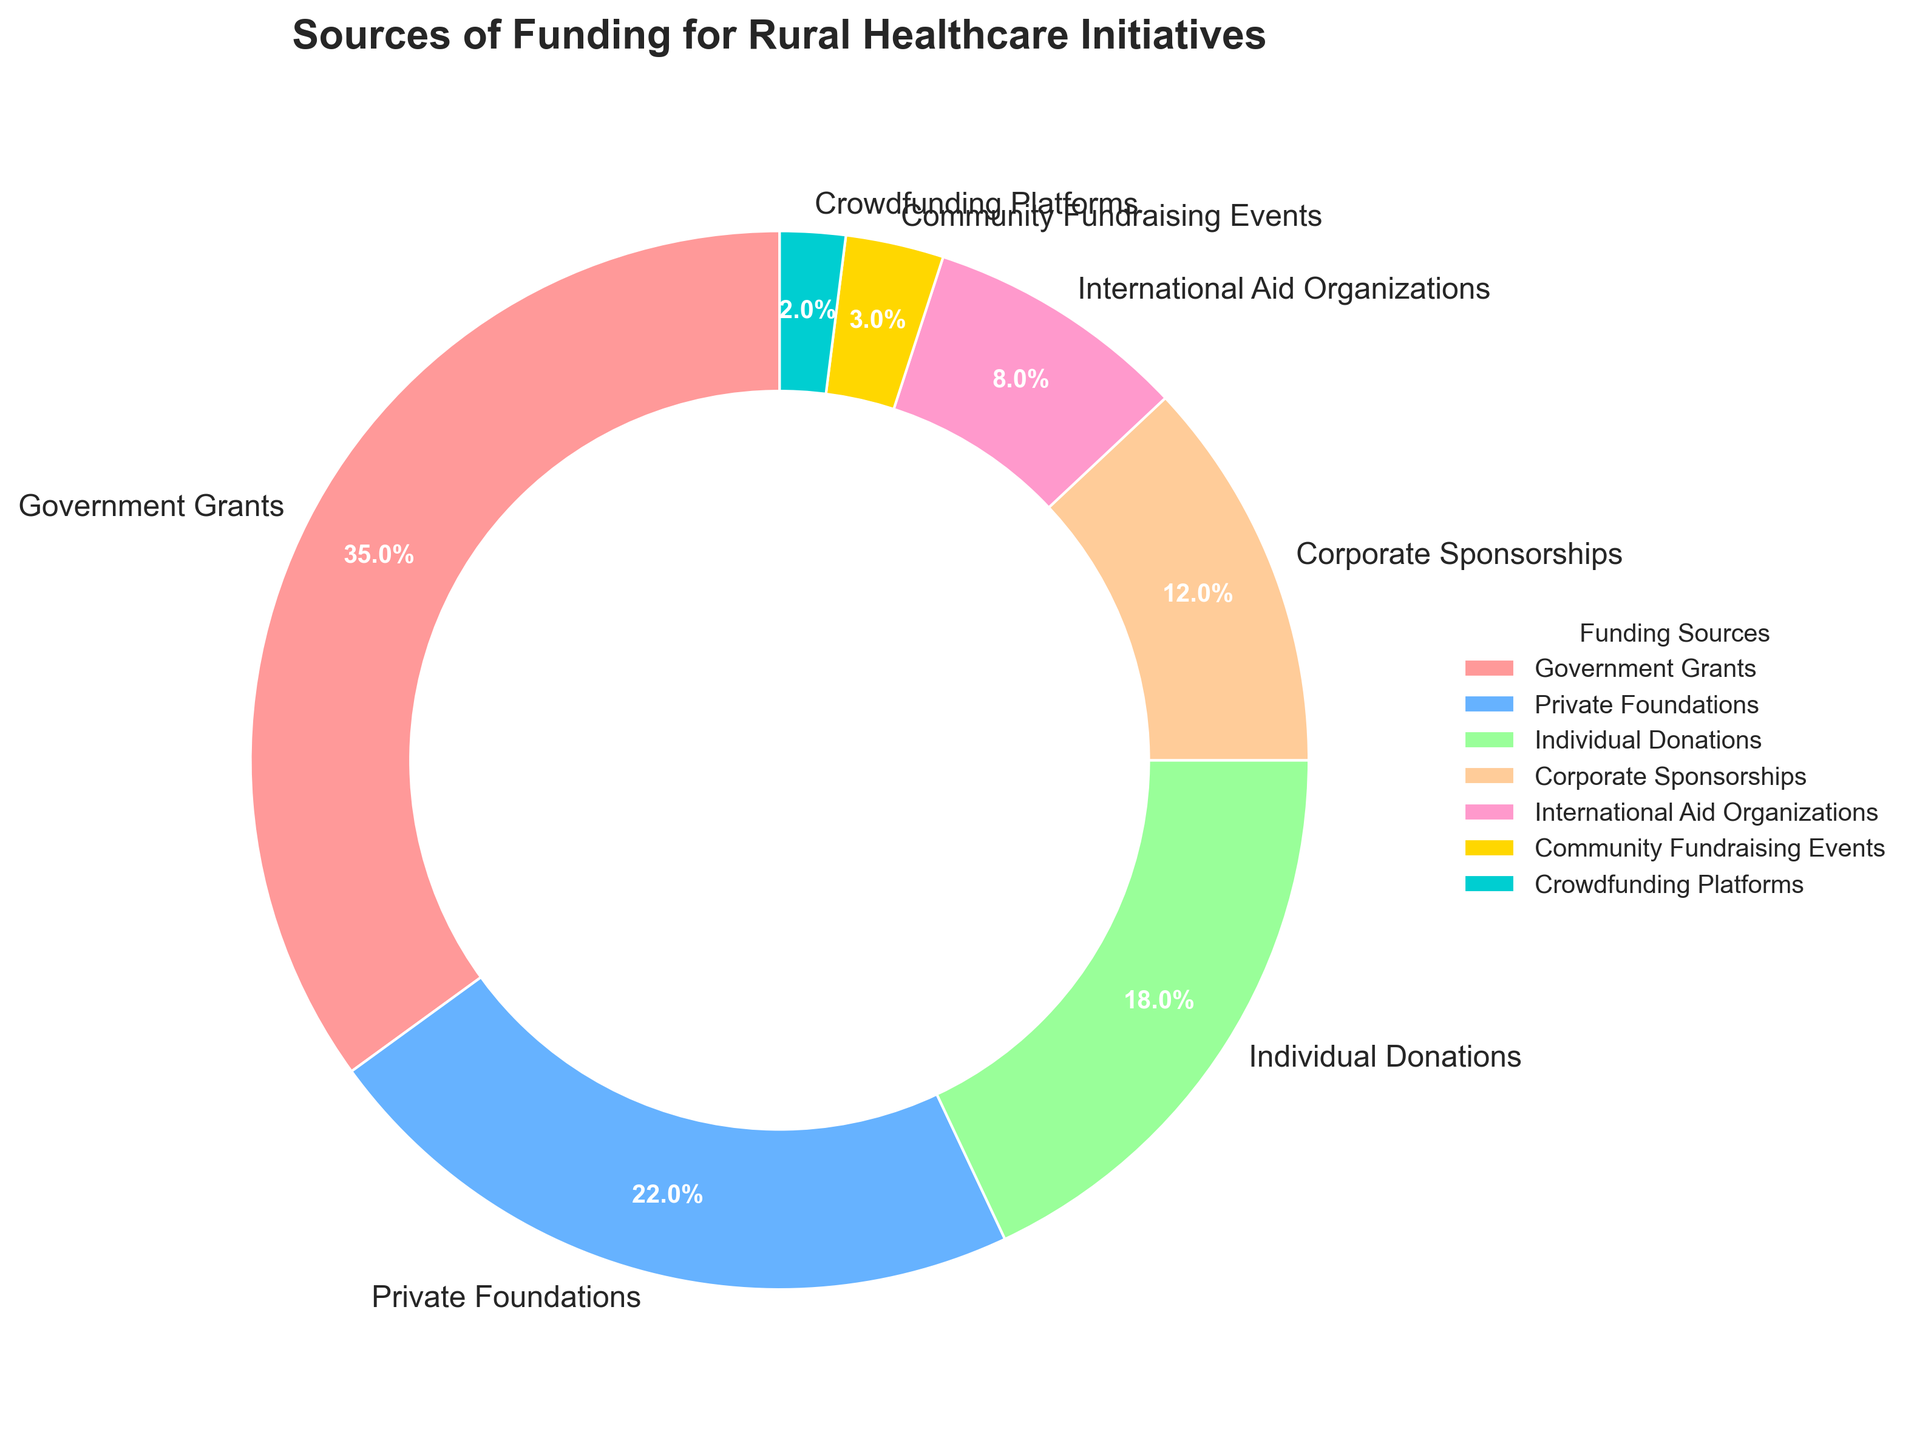What is the largest source of funding for rural healthcare initiatives? The largest segment in the pie chart is the one for Government Grants. It is visually the largest and constitutes 35% of the total funding.
Answer: Government Grants Which two funding sources together make up more than half of the total funding? Government Grants (35%) and Private Foundations (22%) together total 35% + 22% = 57%, which is more than half of the total funding.
Answer: Government Grants and Private Foundations How much more percentage does Individual Donations contribute compared to Corporate Sponsorships? Individual Donations contribute 18% while Corporate Sponsorships contribute 12%. The difference is 18% - 12% = 6%.
Answer: 6% What is the combined percentage of funding from International Aid Organizations, Community Fundraising Events, and Crowdfunding Platforms? The percentages are 8%, 3%, and 2% respectively. Combined, they total 8% + 3% + 2% = 13%.
Answer: 13% Which funding source is represented by the smallest slice in the chart? The smallest slice in the pie chart corresponds to Crowdfunding Platforms, which contribute 2%.
Answer: Crowdfunding Platforms Is the contribution from Private Foundations greater than the combined contribution from International Aid Organizations and Crowdfunding Platforms? Private Foundations contribute 22%. The combined contribution from International Aid Organizations (8%) and Crowdfunding Platforms (2%) is 8% + 2% = 10%, which is less than 22%.
Answer: Yes How does the visual size of the Corporate Sponsorships segment compare with the Community Fundraising Events segment? The Corporate Sponsorships segment is larger than the Community Fundraising Events segment. Corporate Sponsorships constitute 12%, whereas Community Fundraising Events constitute only 3%.
Answer: Corporate Sponsorships is larger Which slice is colored with the light blue color and what is its percentage? The light blue-colored slice represents Private Foundations and it constitutes 22% of the total funding.
Answer: Private Foundations, 22% If we group all individual contributions together (Individual Donations and Crowdfunding Platforms), what is their total contribution? Individual Donations contribute 18% and Crowdfunding Platforms contribute 2%. Together, they total 18% + 2% = 20%.
Answer: 20% 